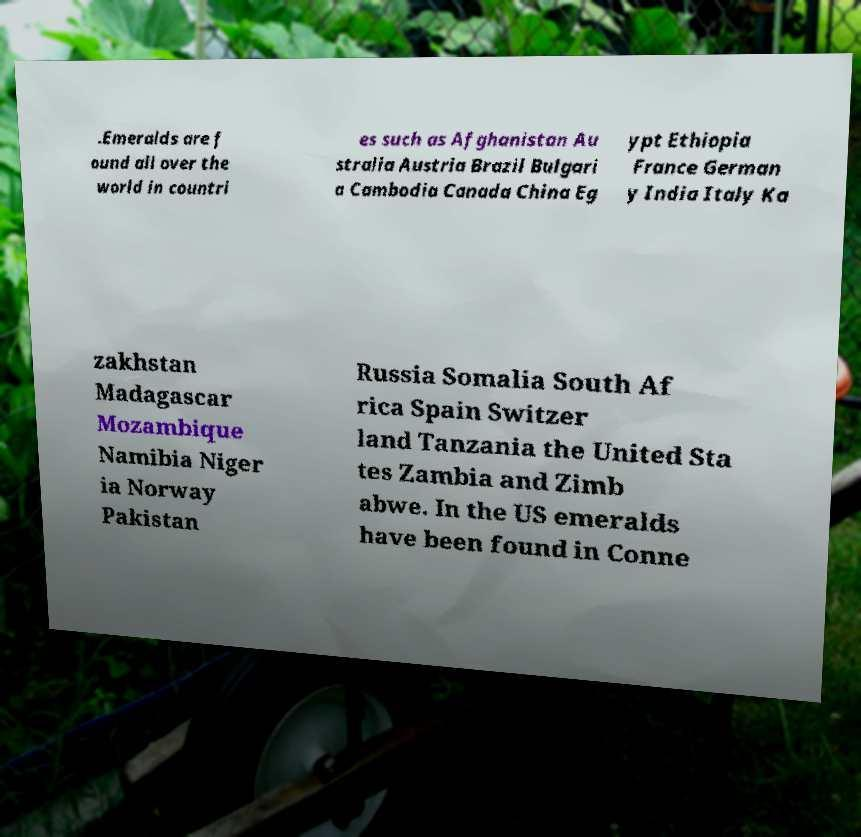What messages or text are displayed in this image? I need them in a readable, typed format. .Emeralds are f ound all over the world in countri es such as Afghanistan Au stralia Austria Brazil Bulgari a Cambodia Canada China Eg ypt Ethiopia France German y India Italy Ka zakhstan Madagascar Mozambique Namibia Niger ia Norway Pakistan Russia Somalia South Af rica Spain Switzer land Tanzania the United Sta tes Zambia and Zimb abwe. In the US emeralds have been found in Conne 